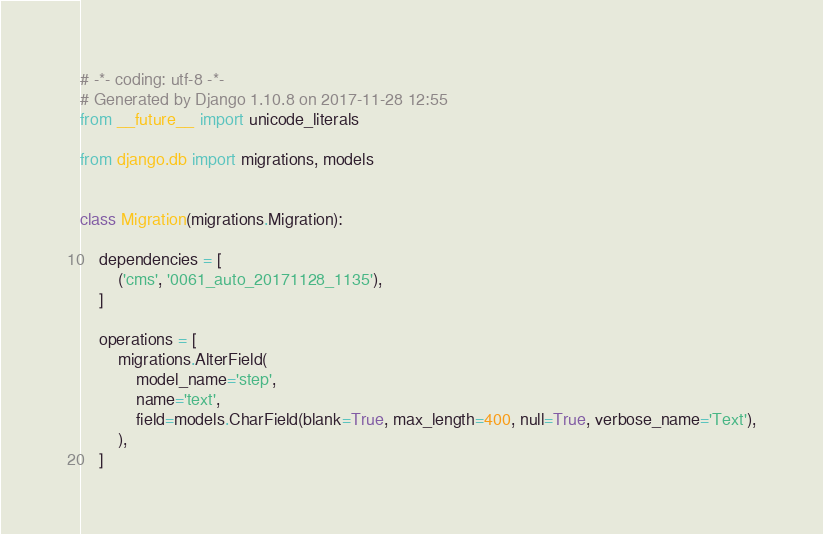Convert code to text. <code><loc_0><loc_0><loc_500><loc_500><_Python_># -*- coding: utf-8 -*-
# Generated by Django 1.10.8 on 2017-11-28 12:55
from __future__ import unicode_literals

from django.db import migrations, models


class Migration(migrations.Migration):

    dependencies = [
        ('cms', '0061_auto_20171128_1135'),
    ]

    operations = [
        migrations.AlterField(
            model_name='step',
            name='text',
            field=models.CharField(blank=True, max_length=400, null=True, verbose_name='Text'),
        ),
    ]
</code> 